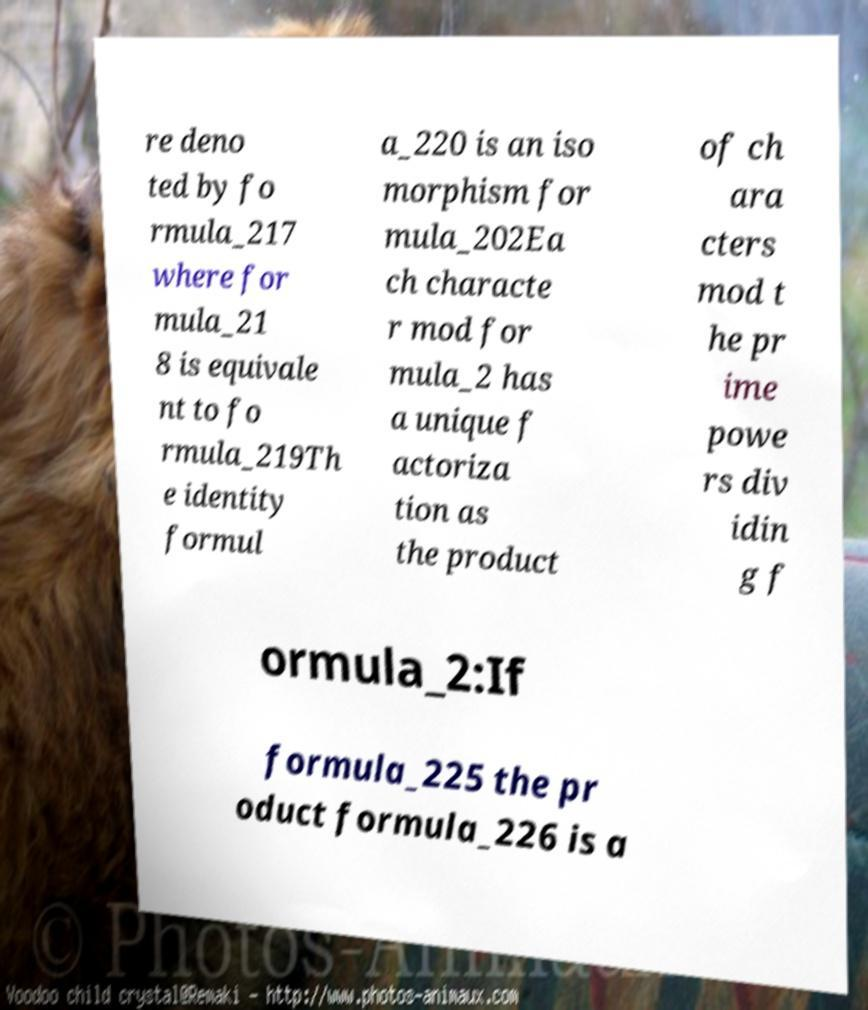For documentation purposes, I need the text within this image transcribed. Could you provide that? re deno ted by fo rmula_217 where for mula_21 8 is equivale nt to fo rmula_219Th e identity formul a_220 is an iso morphism for mula_202Ea ch characte r mod for mula_2 has a unique f actoriza tion as the product of ch ara cters mod t he pr ime powe rs div idin g f ormula_2:If formula_225 the pr oduct formula_226 is a 